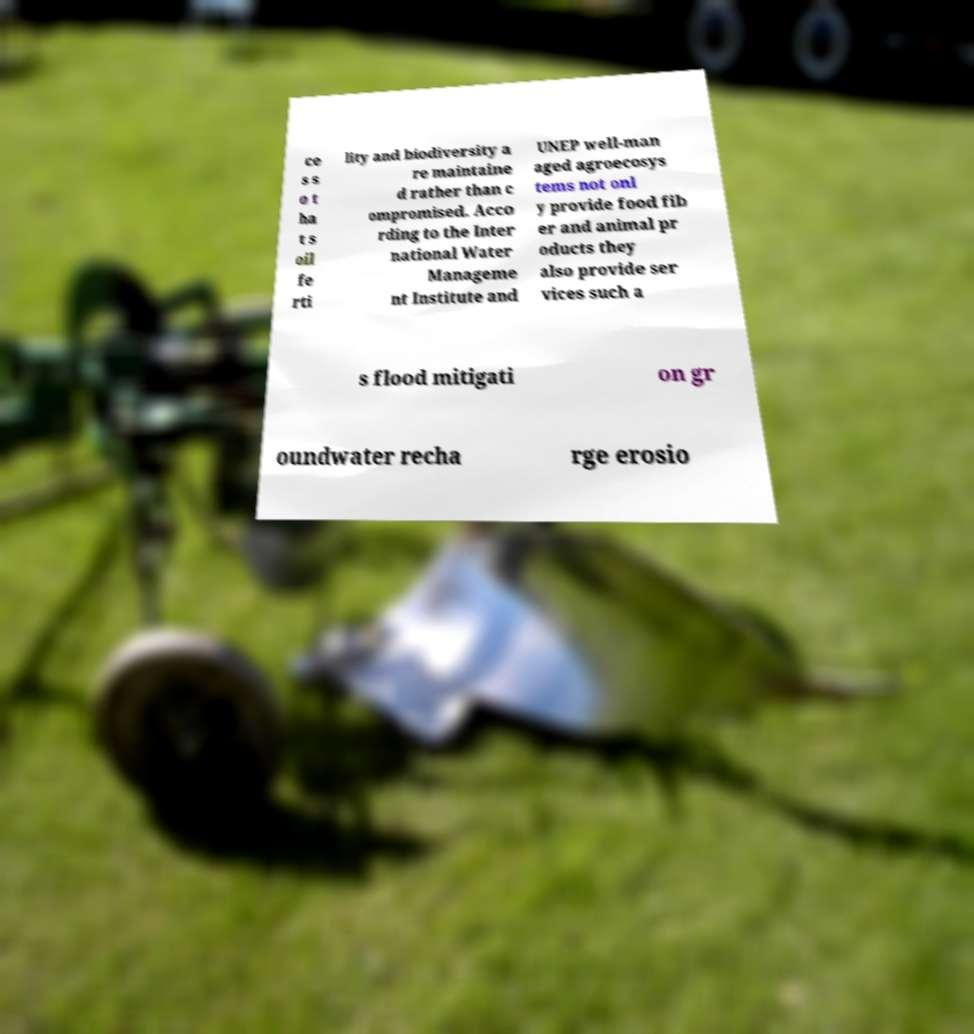What messages or text are displayed in this image? I need them in a readable, typed format. ce s s o t ha t s oil fe rti lity and biodiversity a re maintaine d rather than c ompromised. Acco rding to the Inter national Water Manageme nt Institute and UNEP well-man aged agroecosys tems not onl y provide food fib er and animal pr oducts they also provide ser vices such a s flood mitigati on gr oundwater recha rge erosio 